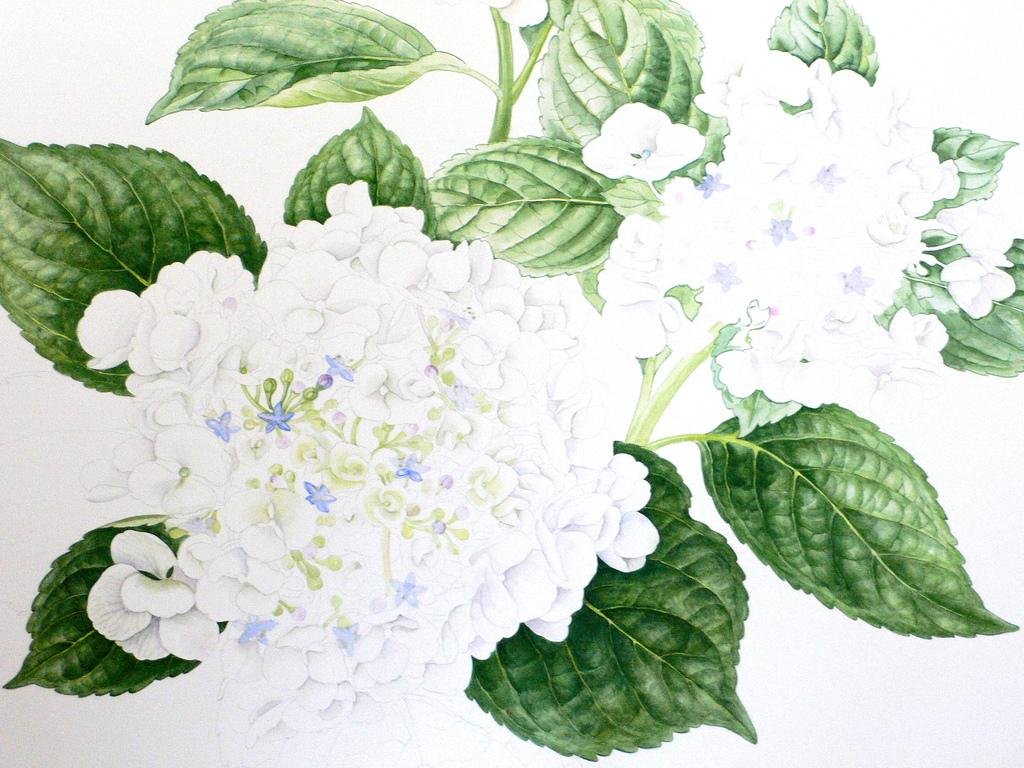What is the main subject of the image? The image contains a painting. What is being depicted in the painting? The painting depicts white flowers. Are there any other colors present in the painting besides white? Yes, the painting includes green color leaves. Can you tell me how many matches are used to create the painting in the image? There is no indication in the image that the painting was created using matches. The painting appears to be a traditional artwork, likely created using paint or other artistic mediums. 